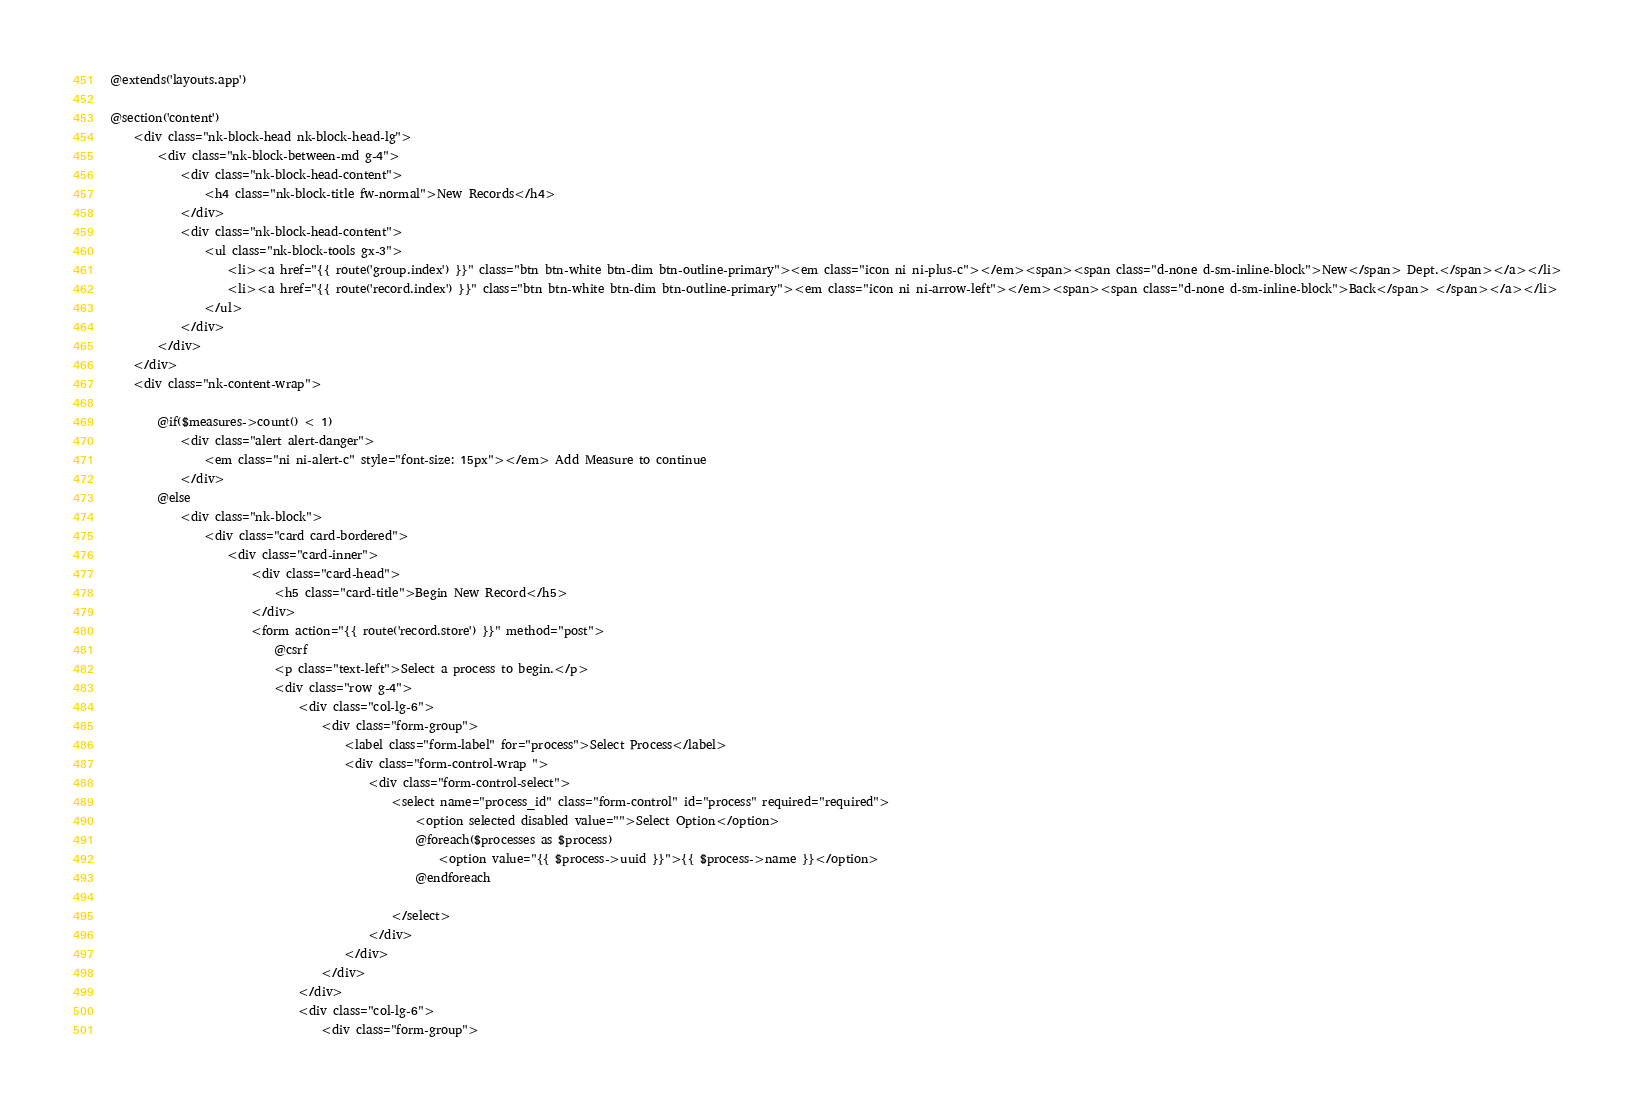<code> <loc_0><loc_0><loc_500><loc_500><_PHP_>@extends('layouts.app')

@section('content')
    <div class="nk-block-head nk-block-head-lg">
        <div class="nk-block-between-md g-4">
            <div class="nk-block-head-content">
                <h4 class="nk-block-title fw-normal">New Records</h4>
            </div>
            <div class="nk-block-head-content">
                <ul class="nk-block-tools gx-3">
                    <li><a href="{{ route('group.index') }}" class="btn btn-white btn-dim btn-outline-primary"><em class="icon ni ni-plus-c"></em><span><span class="d-none d-sm-inline-block">New</span> Dept.</span></a></li>
                    <li><a href="{{ route('record.index') }}" class="btn btn-white btn-dim btn-outline-primary"><em class="icon ni ni-arrow-left"></em><span><span class="d-none d-sm-inline-block">Back</span> </span></a></li>
                </ul>
            </div>
        </div>
    </div>
    <div class="nk-content-wrap">

        @if($measures->count() < 1)
            <div class="alert alert-danger">
                <em class="ni ni-alert-c" style="font-size: 15px"></em> Add Measure to continue
            </div>
        @else
            <div class="nk-block">
                <div class="card card-bordered">
                    <div class="card-inner">
                        <div class="card-head">
                            <h5 class="card-title">Begin New Record</h5>
                        </div>
                        <form action="{{ route('record.store') }}" method="post">
                            @csrf
                            <p class="text-left">Select a process to begin.</p>
                            <div class="row g-4">
                                <div class="col-lg-6">
                                    <div class="form-group">
                                        <label class="form-label" for="process">Select Process</label>
                                        <div class="form-control-wrap ">
                                            <div class="form-control-select">
                                                <select name="process_id" class="form-control" id="process" required="required">
                                                    <option selected disabled value="">Select Option</option>
                                                    @foreach($processes as $process)
                                                        <option value="{{ $process->uuid }}">{{ $process->name }}</option>
                                                    @endforeach

                                                </select>
                                            </div>
                                        </div>
                                    </div>
                                </div>
                                <div class="col-lg-6">
                                    <div class="form-group"></code> 